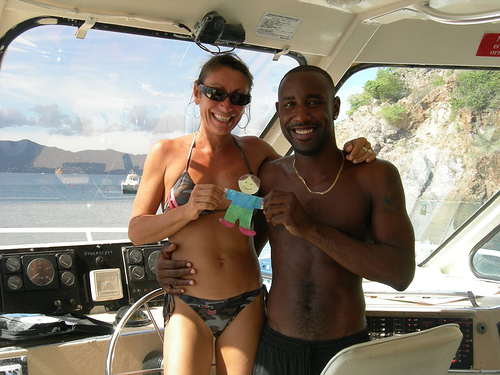<image>
Is there a man on the woman? No. The man is not positioned on the woman. They may be near each other, but the man is not supported by or resting on top of the woman. 